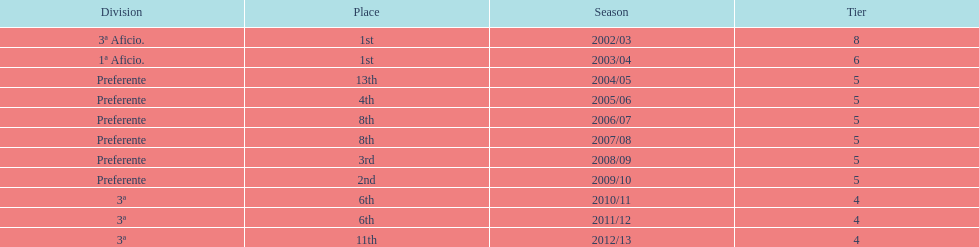Which division placed more than aficio 1a and 3a? Preferente. 